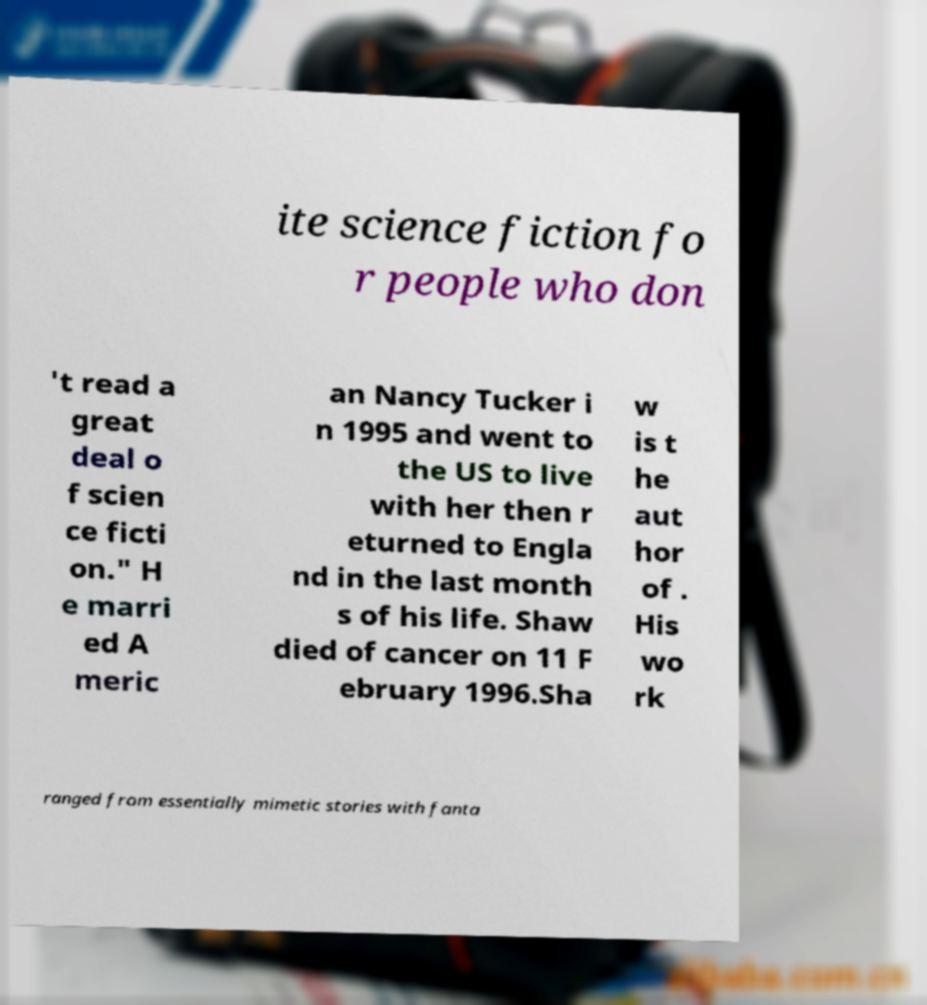For documentation purposes, I need the text within this image transcribed. Could you provide that? ite science fiction fo r people who don 't read a great deal o f scien ce ficti on." H e marri ed A meric an Nancy Tucker i n 1995 and went to the US to live with her then r eturned to Engla nd in the last month s of his life. Shaw died of cancer on 11 F ebruary 1996.Sha w is t he aut hor of . His wo rk ranged from essentially mimetic stories with fanta 